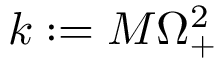<formula> <loc_0><loc_0><loc_500><loc_500>k \colon = M \Omega _ { + } ^ { 2 }</formula> 